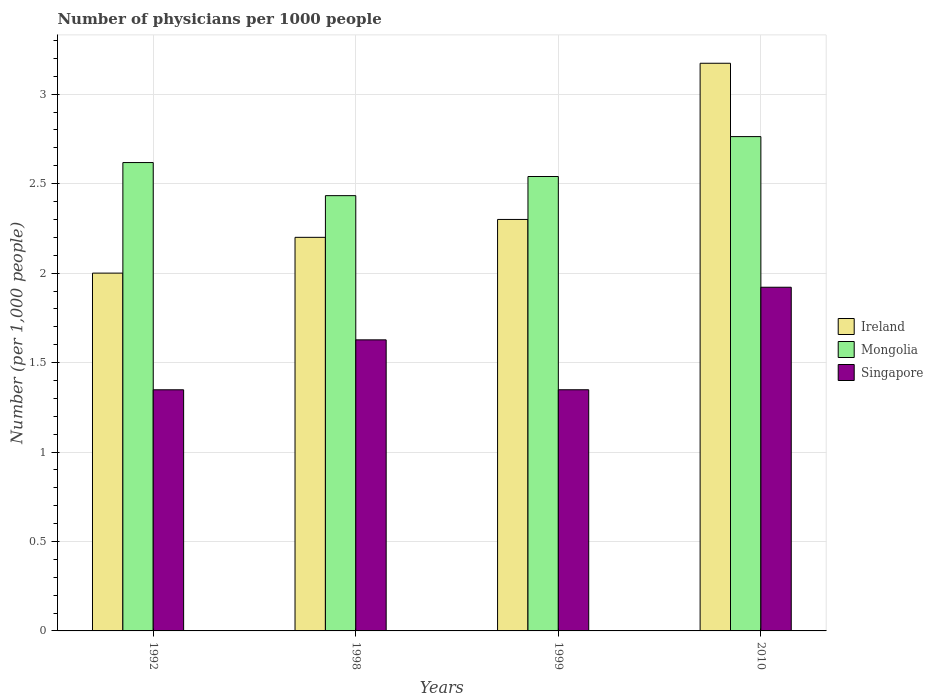How many different coloured bars are there?
Keep it short and to the point. 3. Are the number of bars per tick equal to the number of legend labels?
Offer a very short reply. Yes. How many bars are there on the 2nd tick from the left?
Provide a short and direct response. 3. How many bars are there on the 4th tick from the right?
Provide a succinct answer. 3. In how many cases, is the number of bars for a given year not equal to the number of legend labels?
Provide a short and direct response. 0. What is the number of physicians in Ireland in 2010?
Give a very brief answer. 3.17. Across all years, what is the maximum number of physicians in Ireland?
Offer a terse response. 3.17. Across all years, what is the minimum number of physicians in Ireland?
Give a very brief answer. 2. In which year was the number of physicians in Ireland minimum?
Keep it short and to the point. 1992. What is the total number of physicians in Ireland in the graph?
Your answer should be compact. 9.67. What is the difference between the number of physicians in Mongolia in 1998 and that in 1999?
Ensure brevity in your answer.  -0.11. What is the difference between the number of physicians in Singapore in 1992 and the number of physicians in Mongolia in 2010?
Offer a terse response. -1.42. What is the average number of physicians in Singapore per year?
Ensure brevity in your answer.  1.56. In the year 2010, what is the difference between the number of physicians in Mongolia and number of physicians in Singapore?
Offer a terse response. 0.84. What is the ratio of the number of physicians in Singapore in 1992 to that in 1999?
Offer a very short reply. 1. Is the number of physicians in Mongolia in 1998 less than that in 1999?
Your response must be concise. Yes. Is the difference between the number of physicians in Mongolia in 1992 and 1999 greater than the difference between the number of physicians in Singapore in 1992 and 1999?
Ensure brevity in your answer.  Yes. What is the difference between the highest and the second highest number of physicians in Ireland?
Offer a very short reply. 0.87. What is the difference between the highest and the lowest number of physicians in Mongolia?
Ensure brevity in your answer.  0.33. What does the 3rd bar from the left in 2010 represents?
Give a very brief answer. Singapore. What does the 3rd bar from the right in 1992 represents?
Your answer should be compact. Ireland. Is it the case that in every year, the sum of the number of physicians in Ireland and number of physicians in Mongolia is greater than the number of physicians in Singapore?
Your response must be concise. Yes. How many bars are there?
Ensure brevity in your answer.  12. Are all the bars in the graph horizontal?
Your answer should be very brief. No. How many years are there in the graph?
Your answer should be very brief. 4. What is the difference between two consecutive major ticks on the Y-axis?
Make the answer very short. 0.5. Does the graph contain any zero values?
Your answer should be very brief. No. Where does the legend appear in the graph?
Provide a succinct answer. Center right. How many legend labels are there?
Provide a short and direct response. 3. How are the legend labels stacked?
Your answer should be very brief. Vertical. What is the title of the graph?
Make the answer very short. Number of physicians per 1000 people. Does "Gabon" appear as one of the legend labels in the graph?
Keep it short and to the point. No. What is the label or title of the Y-axis?
Your answer should be compact. Number (per 1,0 people). What is the Number (per 1,000 people) of Mongolia in 1992?
Give a very brief answer. 2.62. What is the Number (per 1,000 people) of Singapore in 1992?
Your response must be concise. 1.35. What is the Number (per 1,000 people) in Ireland in 1998?
Provide a succinct answer. 2.2. What is the Number (per 1,000 people) in Mongolia in 1998?
Your answer should be compact. 2.43. What is the Number (per 1,000 people) of Singapore in 1998?
Provide a short and direct response. 1.63. What is the Number (per 1,000 people) in Ireland in 1999?
Your answer should be very brief. 2.3. What is the Number (per 1,000 people) of Mongolia in 1999?
Offer a terse response. 2.54. What is the Number (per 1,000 people) in Singapore in 1999?
Ensure brevity in your answer.  1.35. What is the Number (per 1,000 people) of Ireland in 2010?
Ensure brevity in your answer.  3.17. What is the Number (per 1,000 people) of Mongolia in 2010?
Provide a succinct answer. 2.76. What is the Number (per 1,000 people) of Singapore in 2010?
Ensure brevity in your answer.  1.92. Across all years, what is the maximum Number (per 1,000 people) of Ireland?
Provide a succinct answer. 3.17. Across all years, what is the maximum Number (per 1,000 people) in Mongolia?
Offer a very short reply. 2.76. Across all years, what is the maximum Number (per 1,000 people) in Singapore?
Ensure brevity in your answer.  1.92. Across all years, what is the minimum Number (per 1,000 people) of Ireland?
Keep it short and to the point. 2. Across all years, what is the minimum Number (per 1,000 people) of Mongolia?
Provide a succinct answer. 2.43. Across all years, what is the minimum Number (per 1,000 people) of Singapore?
Provide a succinct answer. 1.35. What is the total Number (per 1,000 people) in Ireland in the graph?
Provide a succinct answer. 9.67. What is the total Number (per 1,000 people) in Mongolia in the graph?
Your response must be concise. 10.35. What is the total Number (per 1,000 people) of Singapore in the graph?
Keep it short and to the point. 6.24. What is the difference between the Number (per 1,000 people) in Ireland in 1992 and that in 1998?
Make the answer very short. -0.2. What is the difference between the Number (per 1,000 people) in Mongolia in 1992 and that in 1998?
Give a very brief answer. 0.18. What is the difference between the Number (per 1,000 people) of Singapore in 1992 and that in 1998?
Keep it short and to the point. -0.28. What is the difference between the Number (per 1,000 people) of Ireland in 1992 and that in 1999?
Ensure brevity in your answer.  -0.3. What is the difference between the Number (per 1,000 people) in Mongolia in 1992 and that in 1999?
Your answer should be compact. 0.08. What is the difference between the Number (per 1,000 people) of Singapore in 1992 and that in 1999?
Keep it short and to the point. -0. What is the difference between the Number (per 1,000 people) in Ireland in 1992 and that in 2010?
Your response must be concise. -1.17. What is the difference between the Number (per 1,000 people) in Mongolia in 1992 and that in 2010?
Offer a very short reply. -0.14. What is the difference between the Number (per 1,000 people) in Singapore in 1992 and that in 2010?
Make the answer very short. -0.57. What is the difference between the Number (per 1,000 people) in Mongolia in 1998 and that in 1999?
Offer a terse response. -0.11. What is the difference between the Number (per 1,000 people) in Singapore in 1998 and that in 1999?
Your answer should be very brief. 0.28. What is the difference between the Number (per 1,000 people) in Ireland in 1998 and that in 2010?
Make the answer very short. -0.97. What is the difference between the Number (per 1,000 people) in Mongolia in 1998 and that in 2010?
Give a very brief answer. -0.33. What is the difference between the Number (per 1,000 people) of Singapore in 1998 and that in 2010?
Give a very brief answer. -0.29. What is the difference between the Number (per 1,000 people) in Ireland in 1999 and that in 2010?
Make the answer very short. -0.87. What is the difference between the Number (per 1,000 people) of Mongolia in 1999 and that in 2010?
Provide a succinct answer. -0.22. What is the difference between the Number (per 1,000 people) in Singapore in 1999 and that in 2010?
Provide a succinct answer. -0.57. What is the difference between the Number (per 1,000 people) of Ireland in 1992 and the Number (per 1,000 people) of Mongolia in 1998?
Give a very brief answer. -0.43. What is the difference between the Number (per 1,000 people) in Ireland in 1992 and the Number (per 1,000 people) in Singapore in 1998?
Your answer should be very brief. 0.37. What is the difference between the Number (per 1,000 people) in Mongolia in 1992 and the Number (per 1,000 people) in Singapore in 1998?
Provide a succinct answer. 0.99. What is the difference between the Number (per 1,000 people) in Ireland in 1992 and the Number (per 1,000 people) in Mongolia in 1999?
Ensure brevity in your answer.  -0.54. What is the difference between the Number (per 1,000 people) in Ireland in 1992 and the Number (per 1,000 people) in Singapore in 1999?
Make the answer very short. 0.65. What is the difference between the Number (per 1,000 people) in Mongolia in 1992 and the Number (per 1,000 people) in Singapore in 1999?
Make the answer very short. 1.27. What is the difference between the Number (per 1,000 people) in Ireland in 1992 and the Number (per 1,000 people) in Mongolia in 2010?
Give a very brief answer. -0.76. What is the difference between the Number (per 1,000 people) of Ireland in 1992 and the Number (per 1,000 people) of Singapore in 2010?
Your response must be concise. 0.08. What is the difference between the Number (per 1,000 people) in Mongolia in 1992 and the Number (per 1,000 people) in Singapore in 2010?
Provide a succinct answer. 0.7. What is the difference between the Number (per 1,000 people) of Ireland in 1998 and the Number (per 1,000 people) of Mongolia in 1999?
Keep it short and to the point. -0.34. What is the difference between the Number (per 1,000 people) of Ireland in 1998 and the Number (per 1,000 people) of Singapore in 1999?
Provide a short and direct response. 0.85. What is the difference between the Number (per 1,000 people) in Mongolia in 1998 and the Number (per 1,000 people) in Singapore in 1999?
Give a very brief answer. 1.08. What is the difference between the Number (per 1,000 people) in Ireland in 1998 and the Number (per 1,000 people) in Mongolia in 2010?
Your answer should be very brief. -0.56. What is the difference between the Number (per 1,000 people) in Ireland in 1998 and the Number (per 1,000 people) in Singapore in 2010?
Your answer should be compact. 0.28. What is the difference between the Number (per 1,000 people) of Mongolia in 1998 and the Number (per 1,000 people) of Singapore in 2010?
Ensure brevity in your answer.  0.51. What is the difference between the Number (per 1,000 people) in Ireland in 1999 and the Number (per 1,000 people) in Mongolia in 2010?
Keep it short and to the point. -0.46. What is the difference between the Number (per 1,000 people) of Ireland in 1999 and the Number (per 1,000 people) of Singapore in 2010?
Give a very brief answer. 0.38. What is the difference between the Number (per 1,000 people) of Mongolia in 1999 and the Number (per 1,000 people) of Singapore in 2010?
Provide a succinct answer. 0.62. What is the average Number (per 1,000 people) of Ireland per year?
Your answer should be very brief. 2.42. What is the average Number (per 1,000 people) in Mongolia per year?
Your response must be concise. 2.59. What is the average Number (per 1,000 people) in Singapore per year?
Offer a very short reply. 1.56. In the year 1992, what is the difference between the Number (per 1,000 people) of Ireland and Number (per 1,000 people) of Mongolia?
Offer a terse response. -0.62. In the year 1992, what is the difference between the Number (per 1,000 people) of Ireland and Number (per 1,000 people) of Singapore?
Your answer should be compact. 0.65. In the year 1992, what is the difference between the Number (per 1,000 people) of Mongolia and Number (per 1,000 people) of Singapore?
Keep it short and to the point. 1.27. In the year 1998, what is the difference between the Number (per 1,000 people) of Ireland and Number (per 1,000 people) of Mongolia?
Offer a very short reply. -0.23. In the year 1998, what is the difference between the Number (per 1,000 people) in Ireland and Number (per 1,000 people) in Singapore?
Your answer should be compact. 0.57. In the year 1998, what is the difference between the Number (per 1,000 people) of Mongolia and Number (per 1,000 people) of Singapore?
Make the answer very short. 0.81. In the year 1999, what is the difference between the Number (per 1,000 people) in Ireland and Number (per 1,000 people) in Mongolia?
Your answer should be compact. -0.24. In the year 1999, what is the difference between the Number (per 1,000 people) in Mongolia and Number (per 1,000 people) in Singapore?
Give a very brief answer. 1.19. In the year 2010, what is the difference between the Number (per 1,000 people) in Ireland and Number (per 1,000 people) in Mongolia?
Provide a succinct answer. 0.41. In the year 2010, what is the difference between the Number (per 1,000 people) in Ireland and Number (per 1,000 people) in Singapore?
Make the answer very short. 1.25. In the year 2010, what is the difference between the Number (per 1,000 people) in Mongolia and Number (per 1,000 people) in Singapore?
Your response must be concise. 0.84. What is the ratio of the Number (per 1,000 people) in Mongolia in 1992 to that in 1998?
Your answer should be compact. 1.08. What is the ratio of the Number (per 1,000 people) in Singapore in 1992 to that in 1998?
Offer a very short reply. 0.83. What is the ratio of the Number (per 1,000 people) in Ireland in 1992 to that in 1999?
Give a very brief answer. 0.87. What is the ratio of the Number (per 1,000 people) of Mongolia in 1992 to that in 1999?
Your answer should be very brief. 1.03. What is the ratio of the Number (per 1,000 people) in Singapore in 1992 to that in 1999?
Ensure brevity in your answer.  1. What is the ratio of the Number (per 1,000 people) in Ireland in 1992 to that in 2010?
Give a very brief answer. 0.63. What is the ratio of the Number (per 1,000 people) in Mongolia in 1992 to that in 2010?
Your response must be concise. 0.95. What is the ratio of the Number (per 1,000 people) in Singapore in 1992 to that in 2010?
Keep it short and to the point. 0.7. What is the ratio of the Number (per 1,000 people) in Ireland in 1998 to that in 1999?
Your answer should be compact. 0.96. What is the ratio of the Number (per 1,000 people) of Mongolia in 1998 to that in 1999?
Keep it short and to the point. 0.96. What is the ratio of the Number (per 1,000 people) of Singapore in 1998 to that in 1999?
Your answer should be very brief. 1.21. What is the ratio of the Number (per 1,000 people) in Ireland in 1998 to that in 2010?
Offer a terse response. 0.69. What is the ratio of the Number (per 1,000 people) in Mongolia in 1998 to that in 2010?
Make the answer very short. 0.88. What is the ratio of the Number (per 1,000 people) of Singapore in 1998 to that in 2010?
Make the answer very short. 0.85. What is the ratio of the Number (per 1,000 people) in Ireland in 1999 to that in 2010?
Offer a terse response. 0.72. What is the ratio of the Number (per 1,000 people) of Mongolia in 1999 to that in 2010?
Provide a short and direct response. 0.92. What is the ratio of the Number (per 1,000 people) of Singapore in 1999 to that in 2010?
Ensure brevity in your answer.  0.7. What is the difference between the highest and the second highest Number (per 1,000 people) of Ireland?
Offer a very short reply. 0.87. What is the difference between the highest and the second highest Number (per 1,000 people) of Mongolia?
Your answer should be compact. 0.14. What is the difference between the highest and the second highest Number (per 1,000 people) of Singapore?
Your response must be concise. 0.29. What is the difference between the highest and the lowest Number (per 1,000 people) in Ireland?
Offer a terse response. 1.17. What is the difference between the highest and the lowest Number (per 1,000 people) of Mongolia?
Your answer should be very brief. 0.33. What is the difference between the highest and the lowest Number (per 1,000 people) in Singapore?
Your response must be concise. 0.57. 